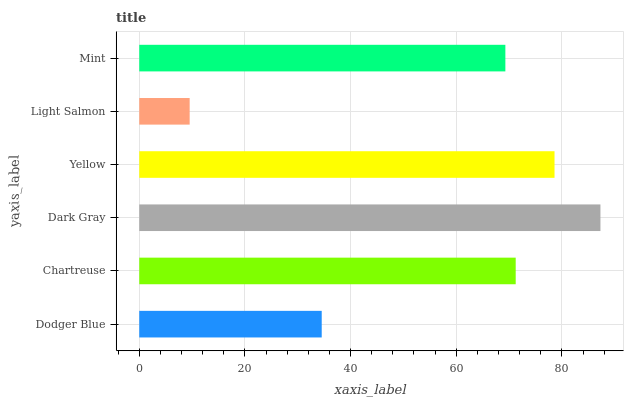Is Light Salmon the minimum?
Answer yes or no. Yes. Is Dark Gray the maximum?
Answer yes or no. Yes. Is Chartreuse the minimum?
Answer yes or no. No. Is Chartreuse the maximum?
Answer yes or no. No. Is Chartreuse greater than Dodger Blue?
Answer yes or no. Yes. Is Dodger Blue less than Chartreuse?
Answer yes or no. Yes. Is Dodger Blue greater than Chartreuse?
Answer yes or no. No. Is Chartreuse less than Dodger Blue?
Answer yes or no. No. Is Chartreuse the high median?
Answer yes or no. Yes. Is Mint the low median?
Answer yes or no. Yes. Is Dodger Blue the high median?
Answer yes or no. No. Is Chartreuse the low median?
Answer yes or no. No. 